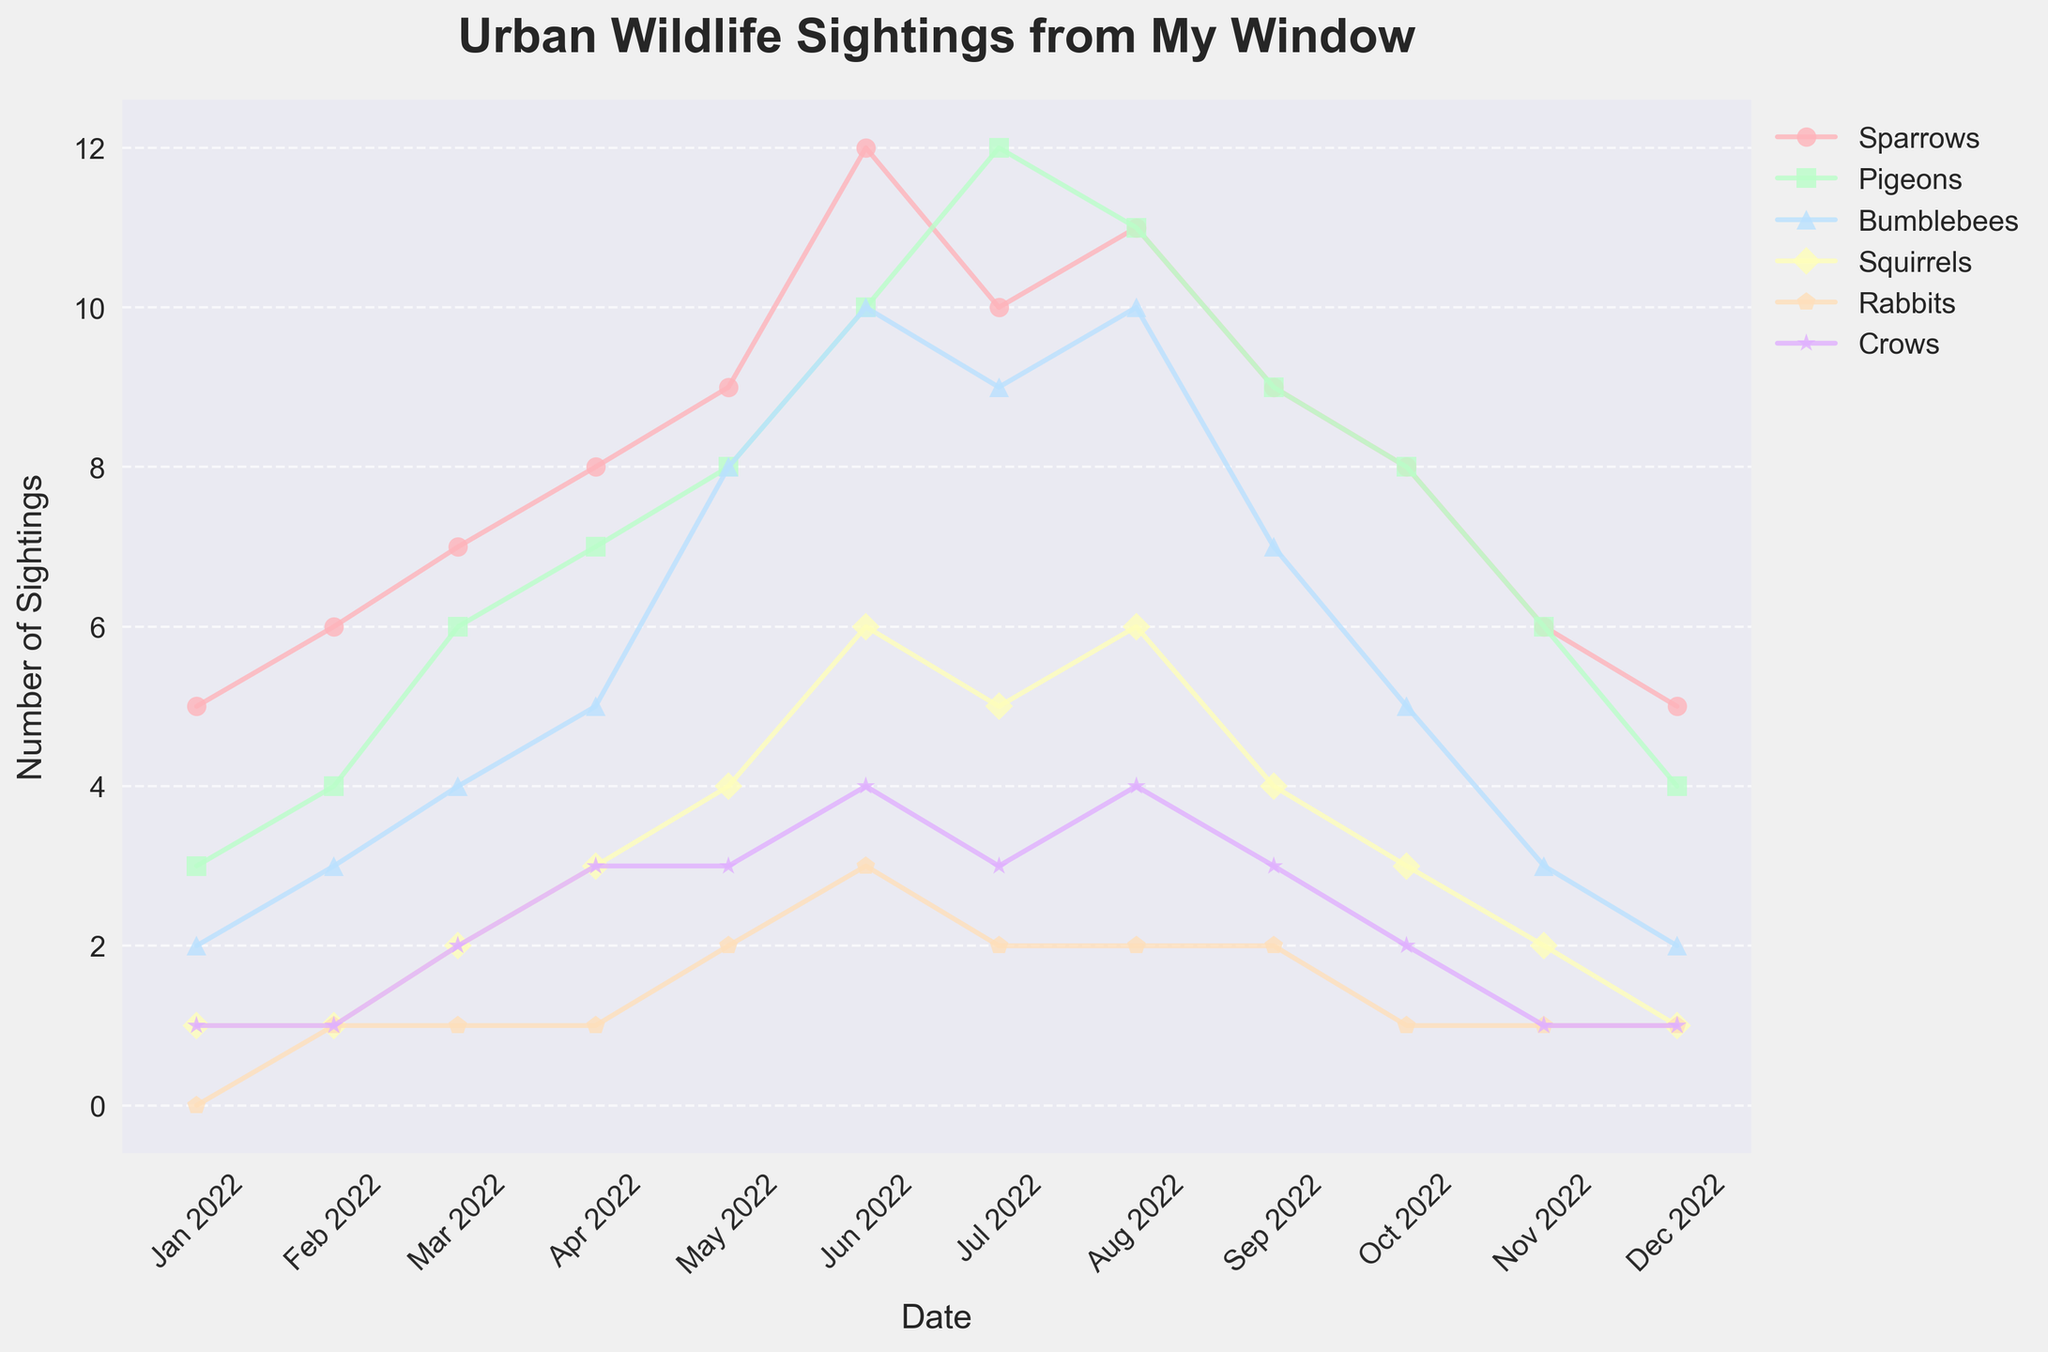What is the title of the figure? The title is usually located at the top of the figure. By observing the figure, the title can be found and read.
Answer: Urban Wildlife Sightings from My Window What does the y-axis represent? The y-axis, often labeled, indicates the measure of the data being plotted. In this case, it represents the number of sightings.
Answer: Number of Sightings Which wildlife was sighted most frequently in June 2022? Looking at the figure for June 2022, identify the highest point along the y-axis for any of the wildlife types indicated by the different colored lines and markers.
Answer: Sparrows How many more Pigeons were sighted in July 2022 compared to January 2022? Check the heights of the Pigeon data points for July 2022 and January 2022, then subtract the number in January from the number in July (12 - 3).
Answer: 9 What month had the lowest number of Squirrel sightings? Look at the line representing Squirrel sightings and identify the lowest point on that line. Check the corresponding month on the x-axis.
Answer: January and December Which wildlife species shows the most consistent trend throughout the year? Observe the trend lines of all species and see which line has the least variability and fluctuations over the months.
Answer: Crows What is the color used to represent Rabbits in the figure? Check the legend in the figure where each species is matched to a color.
Answer: Yellow (#FFFFBA) How many Bumblebees were sighted in total over the year? Sum up the number of sightings for Bumblebees from January to December (2 + 3 + 4 + 5 + 8 + 10 + 9 + 10 + 7 + 5 + 3 + 2).
Answer: 68 During which months were Crow sightings higher than Rabbit sightings? Compare the trend lines of Crows and Rabbits for each month and note the months where Crows are higher than Rabbits.
Answer: March, April, June, August, September, October What is the average number of Sparrow sightings per month? Add up all monthly Sparrow sightings and divide by the number of months (12) ((5 + 6 + 7 + 8 + 9 + 12 + 10 + 11 + 9 + 8 + 6 + 5) / 12).
Answer: 8.25 